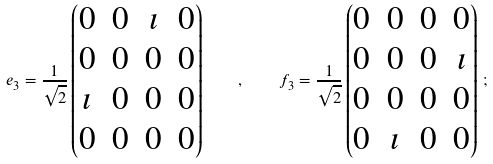<formula> <loc_0><loc_0><loc_500><loc_500>e _ { 3 } = \frac { 1 } { \sqrt { 2 } } \begin{pmatrix} 0 & 0 & \imath & 0 \\ 0 & 0 & 0 & 0 \\ \imath & 0 & 0 & 0 \\ 0 & 0 & 0 & 0 \\ \end{pmatrix} \quad , \quad f _ { 3 } = \frac { 1 } { \sqrt { 2 } } \begin{pmatrix} 0 & 0 & 0 & 0 \\ 0 & 0 & 0 & \imath \\ 0 & 0 & 0 & 0 \\ 0 & \imath & 0 & 0 \\ \end{pmatrix} \, ;</formula> 